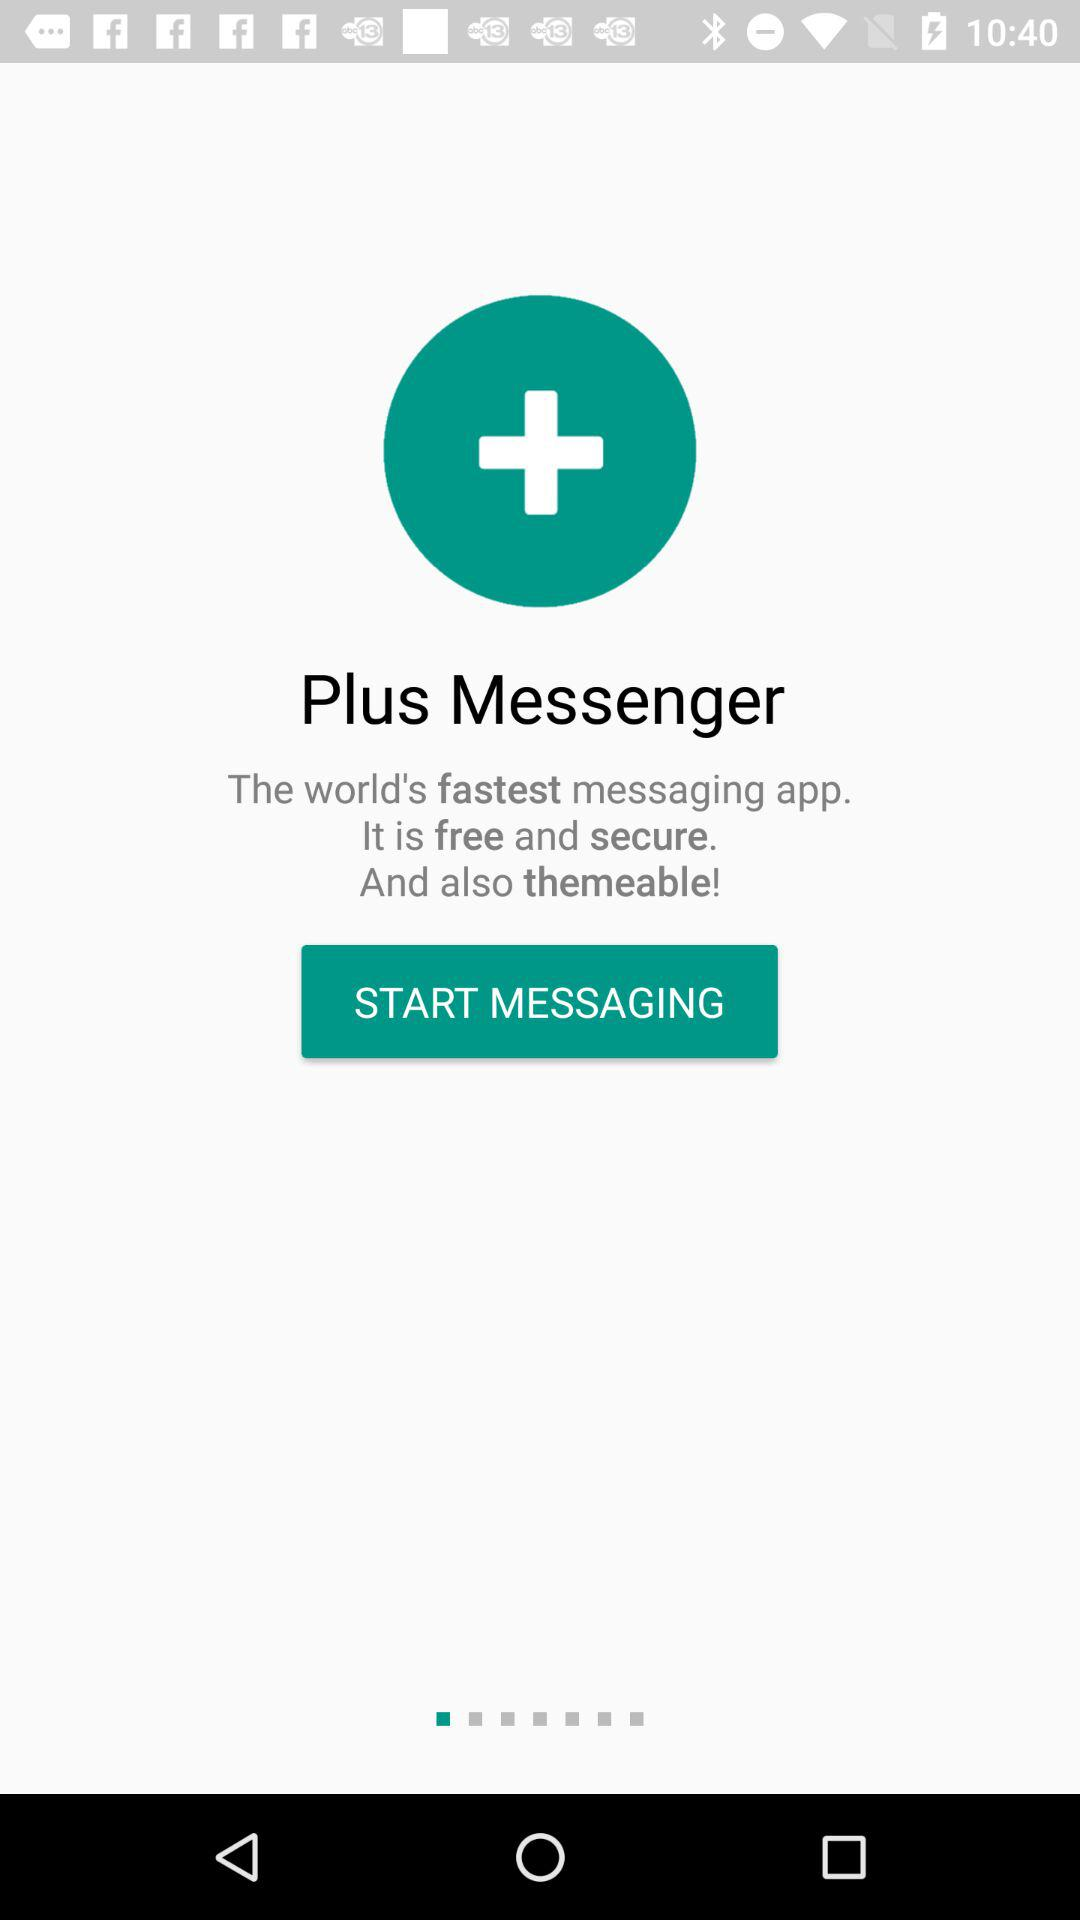What is the name of the application? The name of the application is "Plus Messenger". 